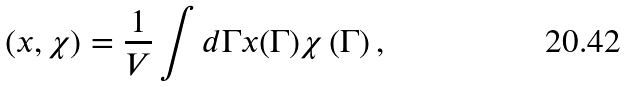<formula> <loc_0><loc_0><loc_500><loc_500>\left ( x , \chi \right ) = \frac { 1 } { V } \int d \Gamma x ( \Gamma ) \chi \left ( \Gamma \right ) ,</formula> 